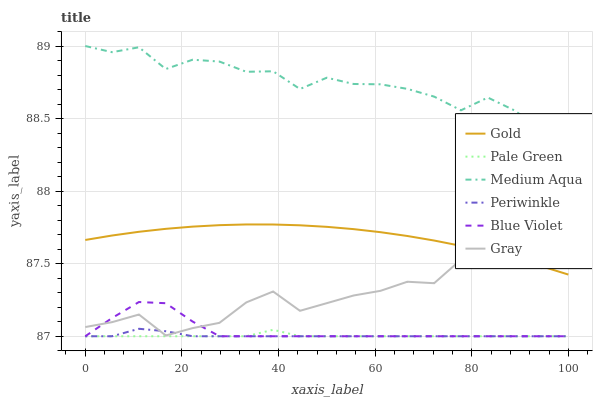Does Pale Green have the minimum area under the curve?
Answer yes or no. Yes. Does Medium Aqua have the maximum area under the curve?
Answer yes or no. Yes. Does Gold have the minimum area under the curve?
Answer yes or no. No. Does Gold have the maximum area under the curve?
Answer yes or no. No. Is Gold the smoothest?
Answer yes or no. Yes. Is Gray the roughest?
Answer yes or no. Yes. Is Pale Green the smoothest?
Answer yes or no. No. Is Pale Green the roughest?
Answer yes or no. No. Does Pale Green have the lowest value?
Answer yes or no. Yes. Does Gold have the lowest value?
Answer yes or no. No. Does Medium Aqua have the highest value?
Answer yes or no. Yes. Does Gold have the highest value?
Answer yes or no. No. Is Blue Violet less than Gold?
Answer yes or no. Yes. Is Gray greater than Pale Green?
Answer yes or no. Yes. Does Gray intersect Periwinkle?
Answer yes or no. Yes. Is Gray less than Periwinkle?
Answer yes or no. No. Is Gray greater than Periwinkle?
Answer yes or no. No. Does Blue Violet intersect Gold?
Answer yes or no. No. 